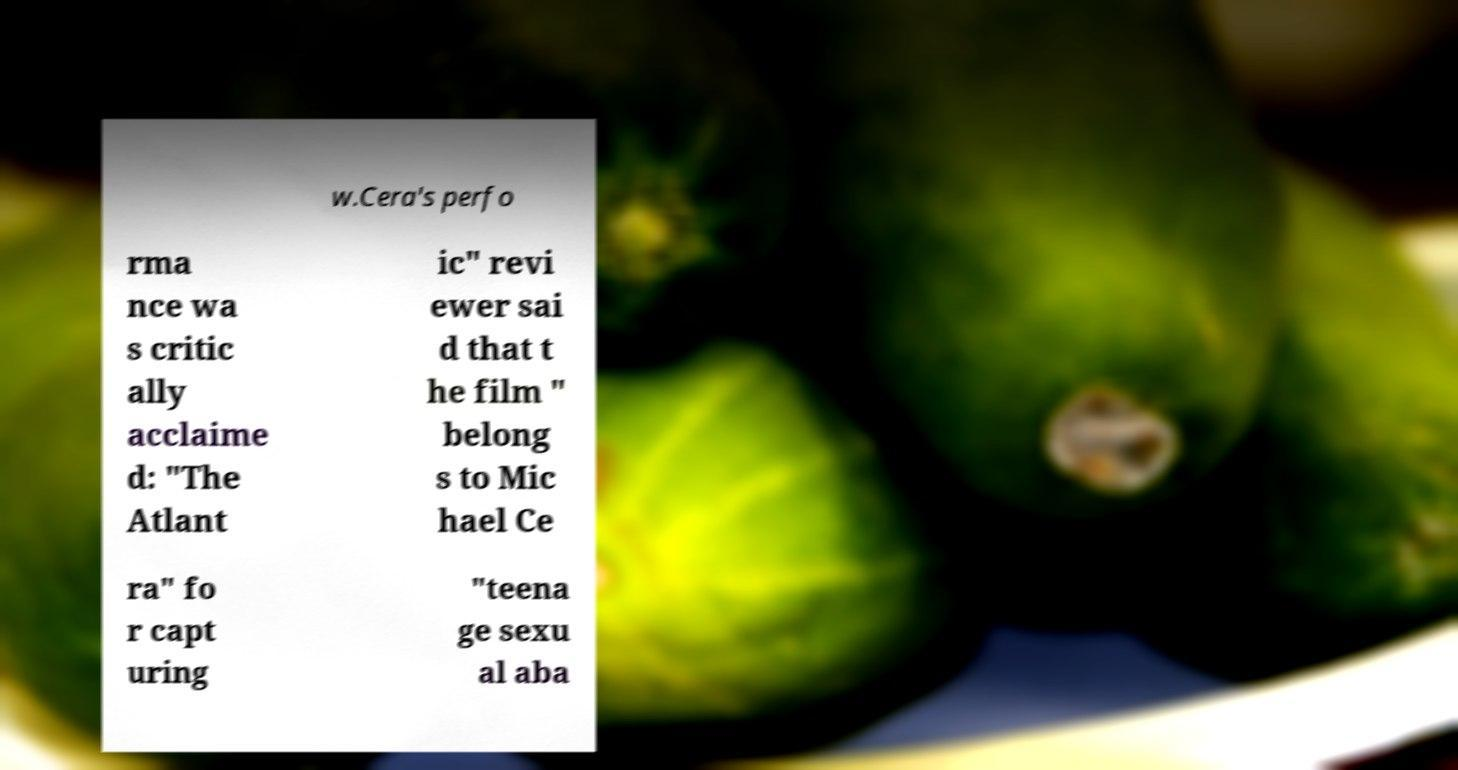Can you read and provide the text displayed in the image?This photo seems to have some interesting text. Can you extract and type it out for me? w.Cera's perfo rma nce wa s critic ally acclaime d: "The Atlant ic" revi ewer sai d that t he film " belong s to Mic hael Ce ra" fo r capt uring "teena ge sexu al aba 